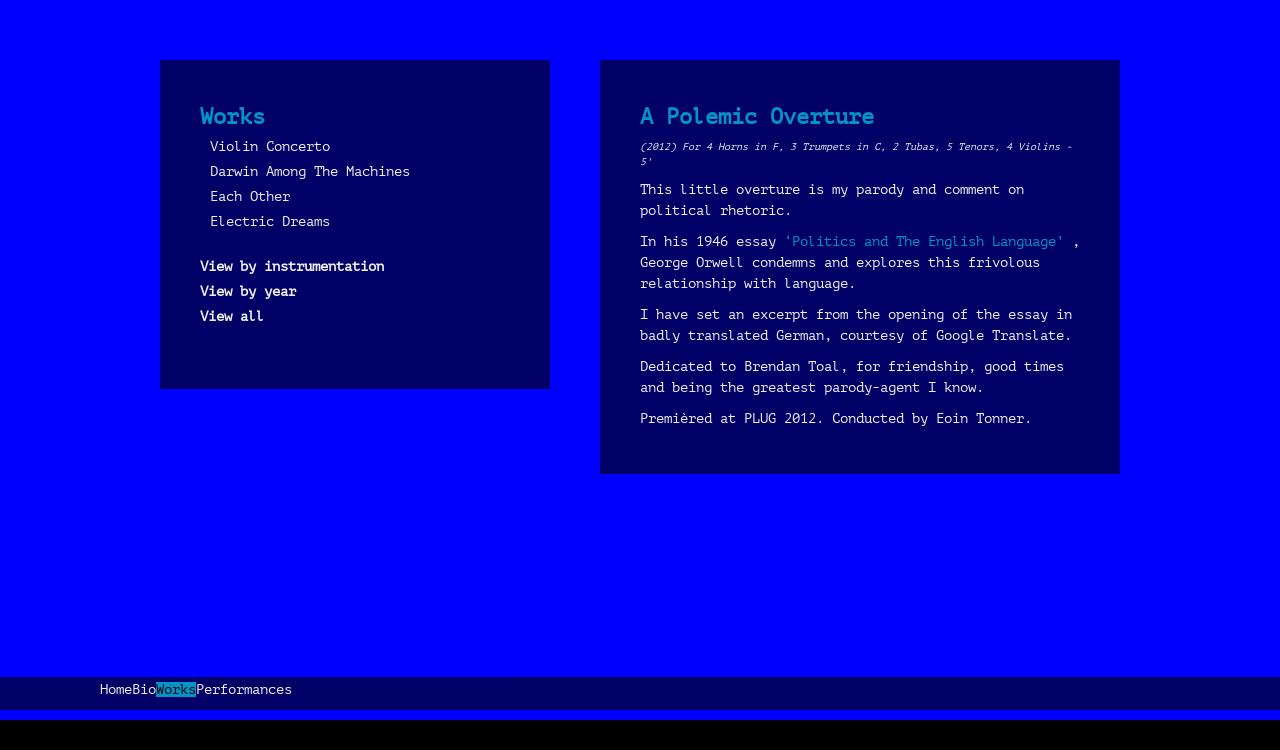What are the other works listed in the 'Works' section on the website? The 'Works' section in the image lists several compositions by Richard Greer, such as 'Violin Concerto', 'Darwin Among The Machines', 'Each Other', and 'Electric Dreams'. Each title suggests a showcase of diverse musical themes and explorations possibly ranging from classical arrangements to interpretations inspired by technological and social themes. 